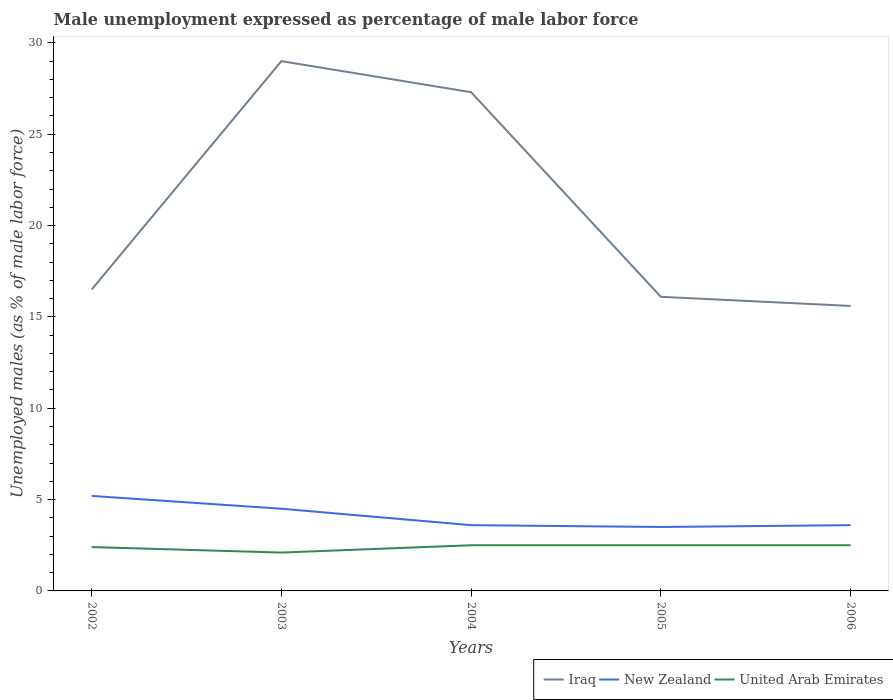Is the number of lines equal to the number of legend labels?
Offer a terse response. Yes. Across all years, what is the maximum unemployment in males in in New Zealand?
Keep it short and to the point. 3.5. What is the total unemployment in males in in Iraq in the graph?
Offer a terse response. 1.7. What is the difference between the highest and the second highest unemployment in males in in Iraq?
Keep it short and to the point. 13.4. How many lines are there?
Make the answer very short. 3. What is the difference between two consecutive major ticks on the Y-axis?
Provide a short and direct response. 5. Does the graph contain grids?
Provide a short and direct response. No. How many legend labels are there?
Provide a short and direct response. 3. How are the legend labels stacked?
Offer a very short reply. Horizontal. What is the title of the graph?
Ensure brevity in your answer.  Male unemployment expressed as percentage of male labor force. What is the label or title of the Y-axis?
Make the answer very short. Unemployed males (as % of male labor force). What is the Unemployed males (as % of male labor force) of Iraq in 2002?
Make the answer very short. 16.5. What is the Unemployed males (as % of male labor force) in New Zealand in 2002?
Your answer should be compact. 5.2. What is the Unemployed males (as % of male labor force) of United Arab Emirates in 2002?
Ensure brevity in your answer.  2.4. What is the Unemployed males (as % of male labor force) in Iraq in 2003?
Your response must be concise. 29. What is the Unemployed males (as % of male labor force) in United Arab Emirates in 2003?
Your response must be concise. 2.1. What is the Unemployed males (as % of male labor force) in Iraq in 2004?
Your response must be concise. 27.3. What is the Unemployed males (as % of male labor force) in New Zealand in 2004?
Provide a short and direct response. 3.6. What is the Unemployed males (as % of male labor force) in United Arab Emirates in 2004?
Give a very brief answer. 2.5. What is the Unemployed males (as % of male labor force) in Iraq in 2005?
Give a very brief answer. 16.1. What is the Unemployed males (as % of male labor force) of New Zealand in 2005?
Give a very brief answer. 3.5. What is the Unemployed males (as % of male labor force) of Iraq in 2006?
Keep it short and to the point. 15.6. What is the Unemployed males (as % of male labor force) of New Zealand in 2006?
Make the answer very short. 3.6. What is the Unemployed males (as % of male labor force) of United Arab Emirates in 2006?
Provide a short and direct response. 2.5. Across all years, what is the maximum Unemployed males (as % of male labor force) in New Zealand?
Provide a succinct answer. 5.2. Across all years, what is the minimum Unemployed males (as % of male labor force) in Iraq?
Your answer should be compact. 15.6. Across all years, what is the minimum Unemployed males (as % of male labor force) in United Arab Emirates?
Offer a very short reply. 2.1. What is the total Unemployed males (as % of male labor force) in Iraq in the graph?
Make the answer very short. 104.5. What is the total Unemployed males (as % of male labor force) in New Zealand in the graph?
Provide a succinct answer. 20.4. What is the difference between the Unemployed males (as % of male labor force) of Iraq in 2002 and that in 2003?
Ensure brevity in your answer.  -12.5. What is the difference between the Unemployed males (as % of male labor force) of United Arab Emirates in 2002 and that in 2003?
Your answer should be compact. 0.3. What is the difference between the Unemployed males (as % of male labor force) in Iraq in 2002 and that in 2004?
Give a very brief answer. -10.8. What is the difference between the Unemployed males (as % of male labor force) of United Arab Emirates in 2002 and that in 2004?
Provide a short and direct response. -0.1. What is the difference between the Unemployed males (as % of male labor force) in New Zealand in 2002 and that in 2005?
Ensure brevity in your answer.  1.7. What is the difference between the Unemployed males (as % of male labor force) of New Zealand in 2003 and that in 2004?
Ensure brevity in your answer.  0.9. What is the difference between the Unemployed males (as % of male labor force) in United Arab Emirates in 2003 and that in 2004?
Provide a short and direct response. -0.4. What is the difference between the Unemployed males (as % of male labor force) in New Zealand in 2003 and that in 2005?
Give a very brief answer. 1. What is the difference between the Unemployed males (as % of male labor force) of United Arab Emirates in 2003 and that in 2005?
Provide a short and direct response. -0.4. What is the difference between the Unemployed males (as % of male labor force) of Iraq in 2003 and that in 2006?
Offer a very short reply. 13.4. What is the difference between the Unemployed males (as % of male labor force) in New Zealand in 2003 and that in 2006?
Offer a very short reply. 0.9. What is the difference between the Unemployed males (as % of male labor force) of Iraq in 2004 and that in 2005?
Make the answer very short. 11.2. What is the difference between the Unemployed males (as % of male labor force) of Iraq in 2004 and that in 2006?
Your response must be concise. 11.7. What is the difference between the Unemployed males (as % of male labor force) in United Arab Emirates in 2004 and that in 2006?
Offer a terse response. 0. What is the difference between the Unemployed males (as % of male labor force) in Iraq in 2002 and the Unemployed males (as % of male labor force) in New Zealand in 2003?
Ensure brevity in your answer.  12. What is the difference between the Unemployed males (as % of male labor force) of Iraq in 2002 and the Unemployed males (as % of male labor force) of United Arab Emirates in 2003?
Give a very brief answer. 14.4. What is the difference between the Unemployed males (as % of male labor force) in Iraq in 2002 and the Unemployed males (as % of male labor force) in New Zealand in 2004?
Give a very brief answer. 12.9. What is the difference between the Unemployed males (as % of male labor force) in Iraq in 2002 and the Unemployed males (as % of male labor force) in United Arab Emirates in 2004?
Make the answer very short. 14. What is the difference between the Unemployed males (as % of male labor force) in New Zealand in 2002 and the Unemployed males (as % of male labor force) in United Arab Emirates in 2004?
Ensure brevity in your answer.  2.7. What is the difference between the Unemployed males (as % of male labor force) in Iraq in 2002 and the Unemployed males (as % of male labor force) in New Zealand in 2005?
Provide a short and direct response. 13. What is the difference between the Unemployed males (as % of male labor force) in New Zealand in 2002 and the Unemployed males (as % of male labor force) in United Arab Emirates in 2006?
Keep it short and to the point. 2.7. What is the difference between the Unemployed males (as % of male labor force) of Iraq in 2003 and the Unemployed males (as % of male labor force) of New Zealand in 2004?
Keep it short and to the point. 25.4. What is the difference between the Unemployed males (as % of male labor force) of Iraq in 2003 and the Unemployed males (as % of male labor force) of United Arab Emirates in 2004?
Offer a terse response. 26.5. What is the difference between the Unemployed males (as % of male labor force) in Iraq in 2003 and the Unemployed males (as % of male labor force) in New Zealand in 2005?
Your response must be concise. 25.5. What is the difference between the Unemployed males (as % of male labor force) of New Zealand in 2003 and the Unemployed males (as % of male labor force) of United Arab Emirates in 2005?
Provide a succinct answer. 2. What is the difference between the Unemployed males (as % of male labor force) of Iraq in 2003 and the Unemployed males (as % of male labor force) of New Zealand in 2006?
Keep it short and to the point. 25.4. What is the difference between the Unemployed males (as % of male labor force) in Iraq in 2003 and the Unemployed males (as % of male labor force) in United Arab Emirates in 2006?
Ensure brevity in your answer.  26.5. What is the difference between the Unemployed males (as % of male labor force) in Iraq in 2004 and the Unemployed males (as % of male labor force) in New Zealand in 2005?
Your answer should be compact. 23.8. What is the difference between the Unemployed males (as % of male labor force) in Iraq in 2004 and the Unemployed males (as % of male labor force) in United Arab Emirates in 2005?
Your response must be concise. 24.8. What is the difference between the Unemployed males (as % of male labor force) in New Zealand in 2004 and the Unemployed males (as % of male labor force) in United Arab Emirates in 2005?
Provide a short and direct response. 1.1. What is the difference between the Unemployed males (as % of male labor force) of Iraq in 2004 and the Unemployed males (as % of male labor force) of New Zealand in 2006?
Provide a short and direct response. 23.7. What is the difference between the Unemployed males (as % of male labor force) in Iraq in 2004 and the Unemployed males (as % of male labor force) in United Arab Emirates in 2006?
Offer a terse response. 24.8. What is the difference between the Unemployed males (as % of male labor force) of New Zealand in 2004 and the Unemployed males (as % of male labor force) of United Arab Emirates in 2006?
Keep it short and to the point. 1.1. What is the average Unemployed males (as % of male labor force) in Iraq per year?
Provide a succinct answer. 20.9. What is the average Unemployed males (as % of male labor force) in New Zealand per year?
Your answer should be very brief. 4.08. What is the average Unemployed males (as % of male labor force) of United Arab Emirates per year?
Keep it short and to the point. 2.4. In the year 2002, what is the difference between the Unemployed males (as % of male labor force) in Iraq and Unemployed males (as % of male labor force) in New Zealand?
Offer a terse response. 11.3. In the year 2002, what is the difference between the Unemployed males (as % of male labor force) of New Zealand and Unemployed males (as % of male labor force) of United Arab Emirates?
Your answer should be compact. 2.8. In the year 2003, what is the difference between the Unemployed males (as % of male labor force) in Iraq and Unemployed males (as % of male labor force) in United Arab Emirates?
Make the answer very short. 26.9. In the year 2004, what is the difference between the Unemployed males (as % of male labor force) of Iraq and Unemployed males (as % of male labor force) of New Zealand?
Offer a very short reply. 23.7. In the year 2004, what is the difference between the Unemployed males (as % of male labor force) in Iraq and Unemployed males (as % of male labor force) in United Arab Emirates?
Provide a succinct answer. 24.8. In the year 2004, what is the difference between the Unemployed males (as % of male labor force) in New Zealand and Unemployed males (as % of male labor force) in United Arab Emirates?
Make the answer very short. 1.1. In the year 2005, what is the difference between the Unemployed males (as % of male labor force) of Iraq and Unemployed males (as % of male labor force) of New Zealand?
Provide a short and direct response. 12.6. In the year 2006, what is the difference between the Unemployed males (as % of male labor force) in Iraq and Unemployed males (as % of male labor force) in New Zealand?
Make the answer very short. 12. In the year 2006, what is the difference between the Unemployed males (as % of male labor force) in Iraq and Unemployed males (as % of male labor force) in United Arab Emirates?
Provide a short and direct response. 13.1. What is the ratio of the Unemployed males (as % of male labor force) in Iraq in 2002 to that in 2003?
Your response must be concise. 0.57. What is the ratio of the Unemployed males (as % of male labor force) of New Zealand in 2002 to that in 2003?
Provide a succinct answer. 1.16. What is the ratio of the Unemployed males (as % of male labor force) in United Arab Emirates in 2002 to that in 2003?
Give a very brief answer. 1.14. What is the ratio of the Unemployed males (as % of male labor force) of Iraq in 2002 to that in 2004?
Keep it short and to the point. 0.6. What is the ratio of the Unemployed males (as % of male labor force) of New Zealand in 2002 to that in 2004?
Your response must be concise. 1.44. What is the ratio of the Unemployed males (as % of male labor force) of Iraq in 2002 to that in 2005?
Provide a succinct answer. 1.02. What is the ratio of the Unemployed males (as % of male labor force) of New Zealand in 2002 to that in 2005?
Provide a succinct answer. 1.49. What is the ratio of the Unemployed males (as % of male labor force) of Iraq in 2002 to that in 2006?
Ensure brevity in your answer.  1.06. What is the ratio of the Unemployed males (as % of male labor force) in New Zealand in 2002 to that in 2006?
Your answer should be very brief. 1.44. What is the ratio of the Unemployed males (as % of male labor force) of Iraq in 2003 to that in 2004?
Offer a very short reply. 1.06. What is the ratio of the Unemployed males (as % of male labor force) in New Zealand in 2003 to that in 2004?
Your answer should be compact. 1.25. What is the ratio of the Unemployed males (as % of male labor force) in United Arab Emirates in 2003 to that in 2004?
Keep it short and to the point. 0.84. What is the ratio of the Unemployed males (as % of male labor force) in Iraq in 2003 to that in 2005?
Ensure brevity in your answer.  1.8. What is the ratio of the Unemployed males (as % of male labor force) of United Arab Emirates in 2003 to that in 2005?
Ensure brevity in your answer.  0.84. What is the ratio of the Unemployed males (as % of male labor force) of Iraq in 2003 to that in 2006?
Offer a very short reply. 1.86. What is the ratio of the Unemployed males (as % of male labor force) in United Arab Emirates in 2003 to that in 2006?
Offer a terse response. 0.84. What is the ratio of the Unemployed males (as % of male labor force) of Iraq in 2004 to that in 2005?
Offer a terse response. 1.7. What is the ratio of the Unemployed males (as % of male labor force) of New Zealand in 2004 to that in 2005?
Provide a short and direct response. 1.03. What is the ratio of the Unemployed males (as % of male labor force) in Iraq in 2004 to that in 2006?
Offer a terse response. 1.75. What is the ratio of the Unemployed males (as % of male labor force) in New Zealand in 2004 to that in 2006?
Your response must be concise. 1. What is the ratio of the Unemployed males (as % of male labor force) in Iraq in 2005 to that in 2006?
Your response must be concise. 1.03. What is the ratio of the Unemployed males (as % of male labor force) of New Zealand in 2005 to that in 2006?
Your answer should be very brief. 0.97. What is the difference between the highest and the second highest Unemployed males (as % of male labor force) in Iraq?
Your answer should be very brief. 1.7. What is the difference between the highest and the second highest Unemployed males (as % of male labor force) of New Zealand?
Your answer should be very brief. 0.7. What is the difference between the highest and the lowest Unemployed males (as % of male labor force) of Iraq?
Give a very brief answer. 13.4. 